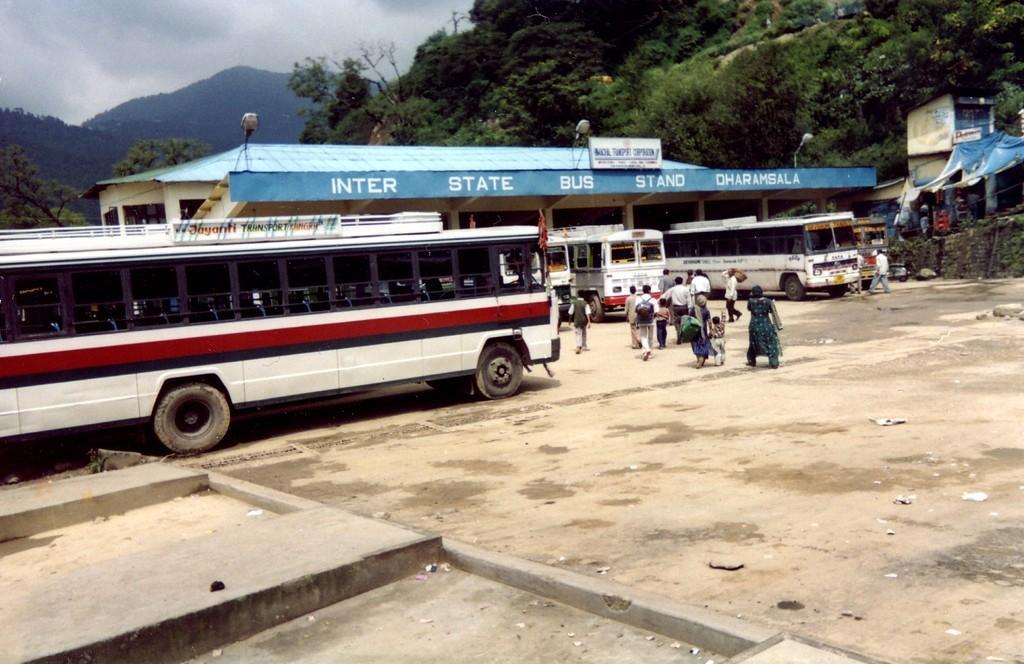Please provide a concise description of this image. In this image we can see the bus stand. And we can see the buses. And we can see people standing. And on the right, we can see a shed. And we can see the hill. And we can see the trees. And we can see the clouds in the sky. 